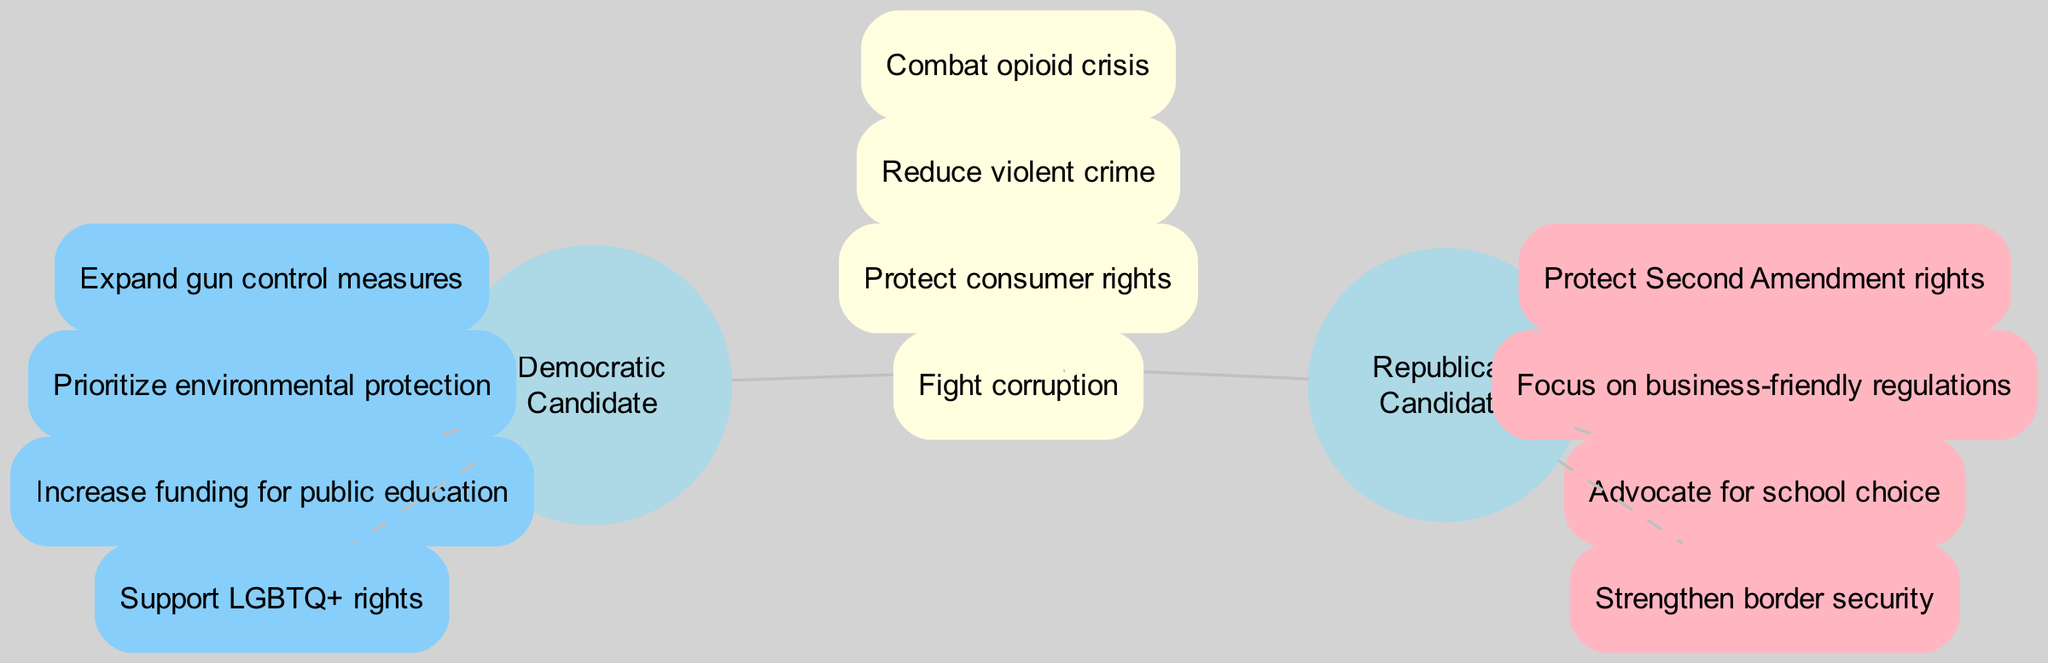What unique element is associated with the Democratic Candidate? The diagram lists "Expand gun control measures" as one of the unique elements associated with the Democratic Candidate. It is located within the circle representing the Democratic Candidate, indicating their specific priority not shared by the Republican Candidate.
Answer: Expand gun control measures How many unique elements does the Republican Candidate have? The diagram shows that the Republican Candidate has four unique elements displayed within their circle. By counting these elements, we find that there are four distinct priorities for the Republican Candidate.
Answer: 4 What is an issue both candidates agree on? The intersection of the two circles displays several issues, including "Combat opioid crisis." This indicates a shared priority between both candidates, reflecting a common ground on this particular issue.
Answer: Combat opioid crisis Which element in the intersection relates to public safety? The element "Reduce violent crime" from the intersection specifically relates to public safety, indicating that both candidates prioritize this concern. By examining the intersection, we identify this as a focus shared by both parties.
Answer: Reduce violent crime What is one unique priority of the Republican Candidate? The Republican Candidate's unique circle includes "Protect Second Amendment rights," demonstrating a priority distinct from those of the Democratic Candidate, showcasing a different ideological stance on gun rights.
Answer: Protect Second Amendment rights How many total elements are in the intersection? The intersection part of the diagram includes four elements, all of which represent common priorities shared by both candidates. By counting these, we determine the total number as four.
Answer: 4 Which party supports LGBTQ+ rights according to the diagram? The diagram indicates that "Support LGBTQ+ rights" is a unique element within the Democratic Candidate's circle, highlighting their commitment to LGBTQ+ issues, while this is not mentioned in the Republican Candidate's unique elements.
Answer: Democratic Candidate What is the focus of both candidates in terms of corruption? Both candidates list "Fight corruption" in the intersection of their circles, which signifies a shared commitment to addressing this issue within their respective platforms. This shows that tackling corruption is a priority for both.
Answer: Fight corruption 